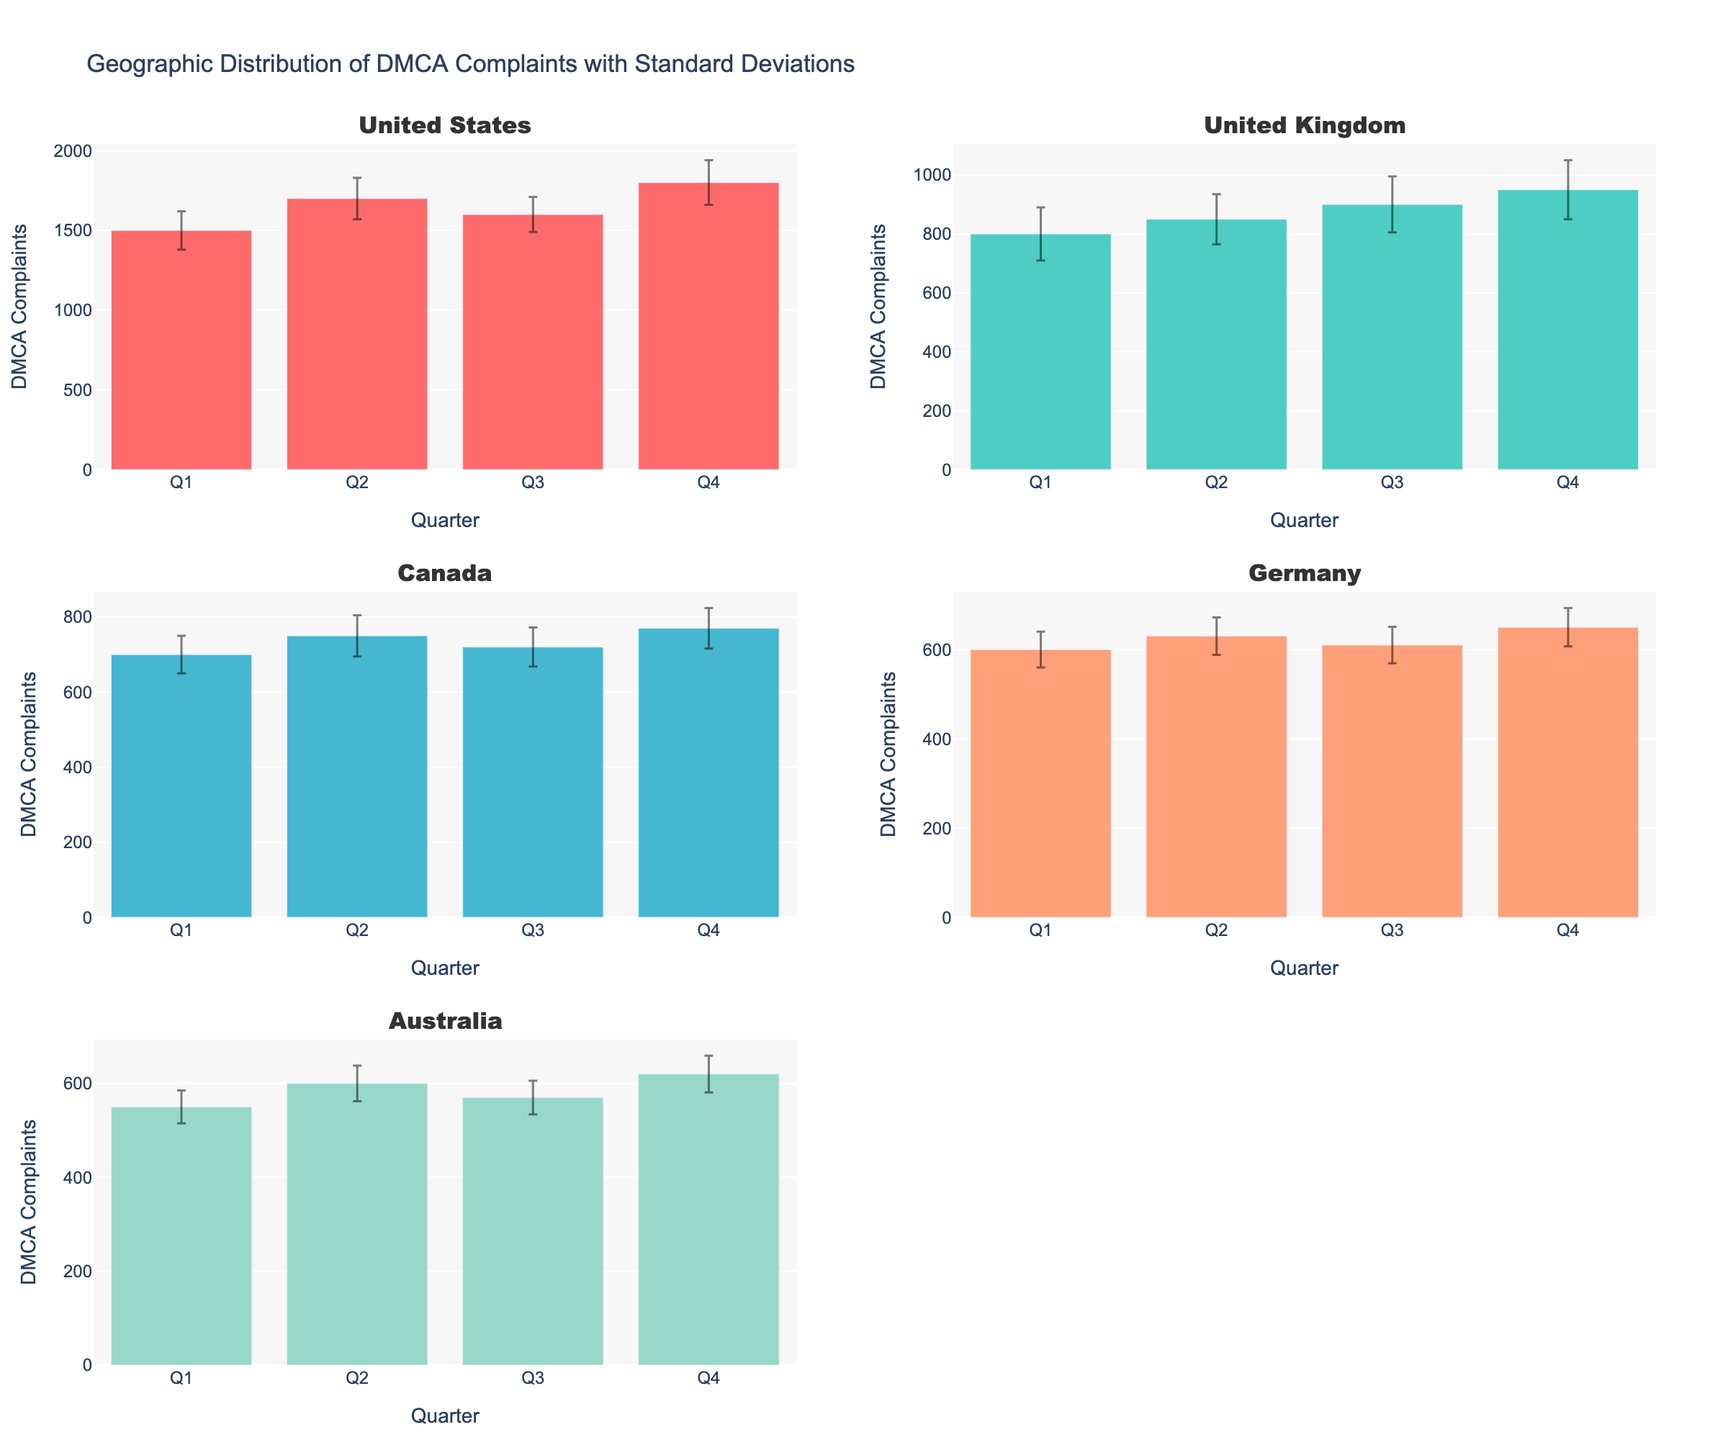What's the title of the figure? The title is located at the top center of the visual and provides a brief description of the content.
Answer: Geographic Distribution of DMCA Complaints with Standard Deviations Which country has the highest mean DMCA complaints in Q4? By comparing the bar heights in Q4 across all subplots, the United States has the highest bar, indicating the highest mean number of DMCA complaints.
Answer: United States What is the mean number of DMCA complaints filed in Q3 for Canada? Locate the subplot for Canada. Find the bar corresponding to Q3 and read the value from the top of the bar or y-axis.
Answer: 720 What is the difference between the mean DMCA complaints in Q2 and Q4 for Germany? From Germany's subplot, read the mean values of Q2 (630) and Q4 (650). Subtract 630 from 650.
Answer: 20 Which country shows the smallest standard deviation in Q1? Assess the size of the error bars in Q1 across all subplots. The smallest error bar denotes the smallest standard deviation. Australia has the smallest error bar in Q1.
Answer: Australia How many countries have a mean DMCA complaint count above 600 in every quarter? Check each country's subplot and ensure all quarterly mean values are above 600. Only the United States and the United Kingdom meet this criterion.
Answer: 2 Which country's complaints increased the most from Q1 to Q2? Calculate the difference in mean complaints from Q1 to Q2 for each country and determine the largest increase. The United States increased from 1500 to 1700, a difference of 200, which is the largest increase.
Answer: United States What is the average mean DMCA complaints across all quarters for Australia? Add the mean complaints for all quarters for Australia (550 + 600 + 570 + 620) and divide by 4.
Answer: 585 Are there any countries that show a decrease in mean DMCA complaints from Q2 to Q3? Compare the mean values of Q2 and Q3 for each country. Australia shows a decrease from 600 to 570, and Germany shows a decrease from 630 to 610.
Answer: Yes Which quarter does the United Kingdom have the highest standard deviation in DMCA complaints? Check the error bars of the United Kingdom across all quarters. Q4 has the largest error bar, indicating the highest standard deviation.
Answer: Q4 